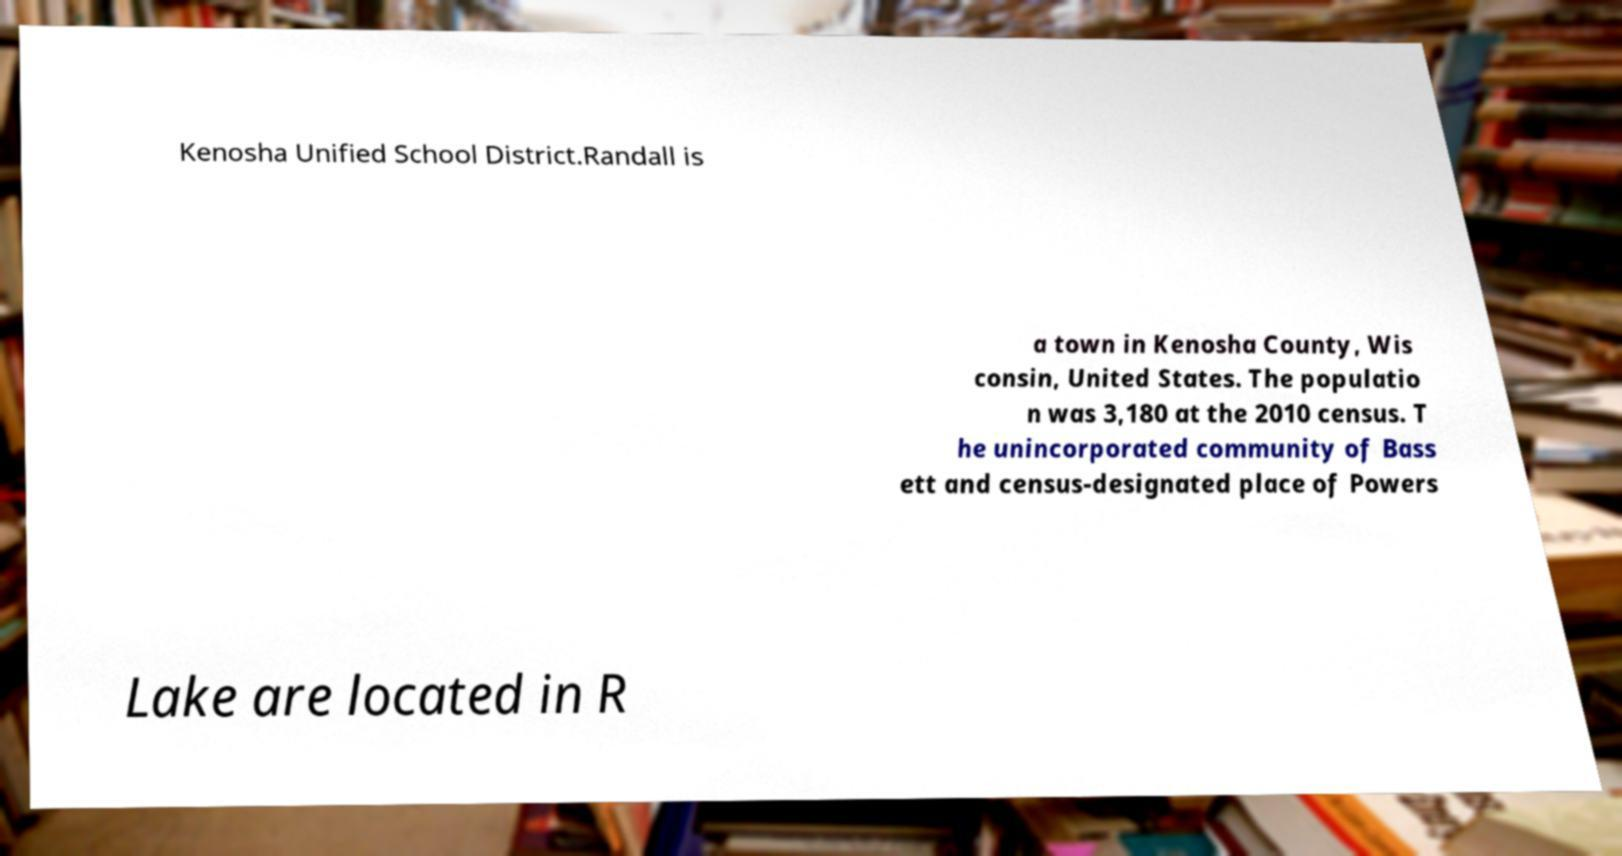There's text embedded in this image that I need extracted. Can you transcribe it verbatim? Kenosha Unified School District.Randall is a town in Kenosha County, Wis consin, United States. The populatio n was 3,180 at the 2010 census. T he unincorporated community of Bass ett and census-designated place of Powers Lake are located in R 